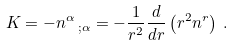Convert formula to latex. <formula><loc_0><loc_0><loc_500><loc_500>K = - n ^ { \alpha } \, _ { ; \alpha } = - \frac { 1 } { r ^ { 2 } } \frac { d } { d r } \left ( r ^ { 2 } n ^ { r } \right ) \, .</formula> 